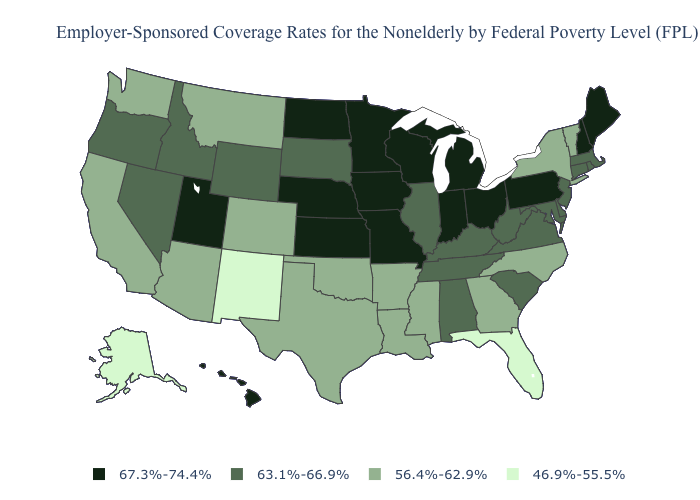Name the states that have a value in the range 63.1%-66.9%?
Quick response, please. Alabama, Connecticut, Delaware, Idaho, Illinois, Kentucky, Maryland, Massachusetts, Nevada, New Jersey, Oregon, Rhode Island, South Carolina, South Dakota, Tennessee, Virginia, West Virginia, Wyoming. What is the value of Idaho?
Write a very short answer. 63.1%-66.9%. Name the states that have a value in the range 56.4%-62.9%?
Keep it brief. Arizona, Arkansas, California, Colorado, Georgia, Louisiana, Mississippi, Montana, New York, North Carolina, Oklahoma, Texas, Vermont, Washington. Does Arkansas have a higher value than Florida?
Keep it brief. Yes. What is the lowest value in the Northeast?
Keep it brief. 56.4%-62.9%. Does the first symbol in the legend represent the smallest category?
Concise answer only. No. Does Maine have the lowest value in the Northeast?
Quick response, please. No. How many symbols are there in the legend?
Give a very brief answer. 4. Among the states that border Maryland , does Pennsylvania have the highest value?
Short answer required. Yes. What is the lowest value in the Northeast?
Give a very brief answer. 56.4%-62.9%. Among the states that border Montana , does North Dakota have the lowest value?
Short answer required. No. Does Ohio have the highest value in the USA?
Write a very short answer. Yes. Among the states that border New York , does Vermont have the lowest value?
Write a very short answer. Yes. What is the value of Montana?
Be succinct. 56.4%-62.9%. Which states have the lowest value in the West?
Short answer required. Alaska, New Mexico. 